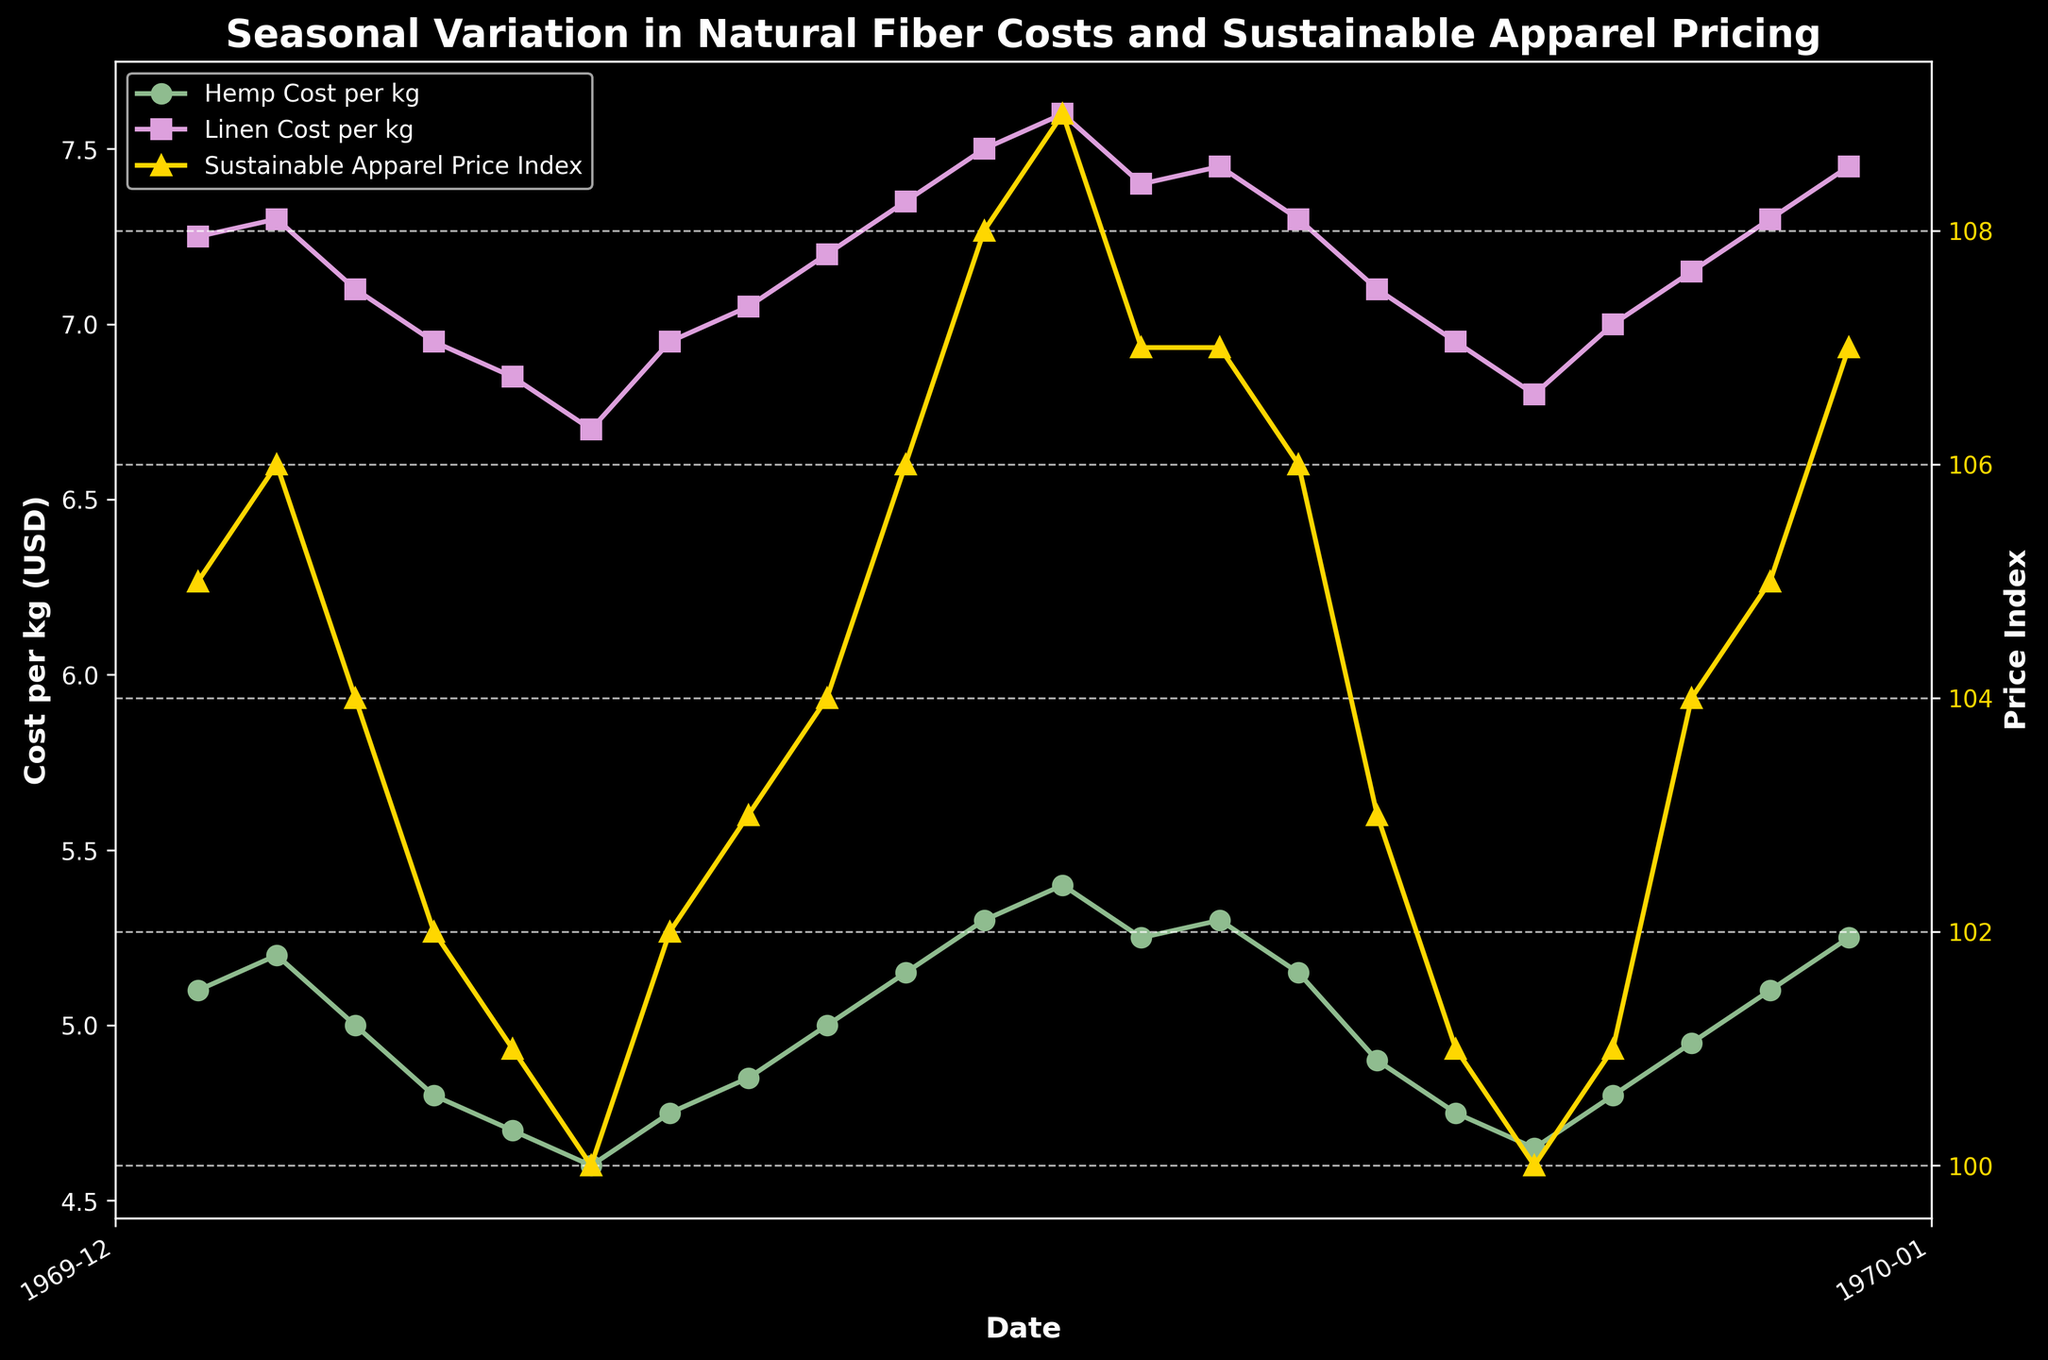What is the title of the plot? The title is displayed at the top of the plot, indicating the main topic or theme being depicted.
Answer: Seasonal Variation in Natural Fiber Costs and Sustainable Apparel Pricing What does the y-axis on the left represent? The y-axis on the left shows the values corresponding to "Hemp Cost per kg" and "Linen Cost per kg." It provides the scale for these two data series.
Answer: Cost per kg (USD) How does the "Hemp Cost per kg" change from January 2022 to December 2022? To find this, follow the "Hemp Cost per kg" line from January 2022 to December 2022 and observe the trend. Hemp cost starts at 5.10 USD per kg, decreases to 4.60 USD per kg in June, and then gradually rises to 5.40 USD per kg in December.
Answer: It decreases initially and then increases In which month(s) are the "Linen Cost per kg" and "Sustainable Apparel Price Index" both at their lowest values? Identify the lowest points of both the "Linen Cost per kg" and "Sustainable Apparel Price Index" lines and see if they coincide. Both are at their lowest in June 2022 with Linen cost at 6.70 USD and the Index at 100.
Answer: June 2022 What is the difference between "Hemp Cost per kg" and "Linen Cost per kg" in December 2022? Subtract the "Hemp Cost per kg" value from the "Linen Cost per kg" value for December 2022 (7.60 - 5.40).
Answer: 2.20 USD Between which months does the "Sustainable Apparel Price Index" remain constant at 107? Follow the "Sustainable Apparel Price Index" data line and look for stretches where it remains constant at 107. It remains constant from January 2023 to February 2023 and again from September 2023 to October 2023.
Answer: January 2023 to February 2023, September 2023 to October 2023 Which fiber's cost shows more fluctuation throughout the period, Hemp or Linen? Compare the 'ups and downs' or deviations of the "Hemp Cost per kg" and "Linen Cost per kg" lines over the period. Linen has higher fluctuations since the range between its minimum and maximum values (1.30 USD) is larger compared to Hemp (0.80 USD).
Answer: Linen What is the average "Sustainable Apparel Price Index" for the year 2022? Sum the "Sustainable Apparel Price Index" values for each month of 2022 and divide by the number of months (12). The values are 105, 106, 104, 102, 101, 100, 102, 103, 104, 106, 108, 109. Sum is 1252, hence the average is 1252/12.
Answer: 104.33 How do "Hemp Cost per kg" and "Linen Cost per kg" relate to each other in February 2023 and March 2023? Compare the values of both fibers for February 2023 and March 2023. In February 2023, Hemp cost (5.30 USD) is lower than Linen (7.45 USD), and the same trend continues in March 2023 with Hemp (5.15 USD) being lower than Linen (7.30 USD).
Answer: Hemp is lower than Linen in both months 